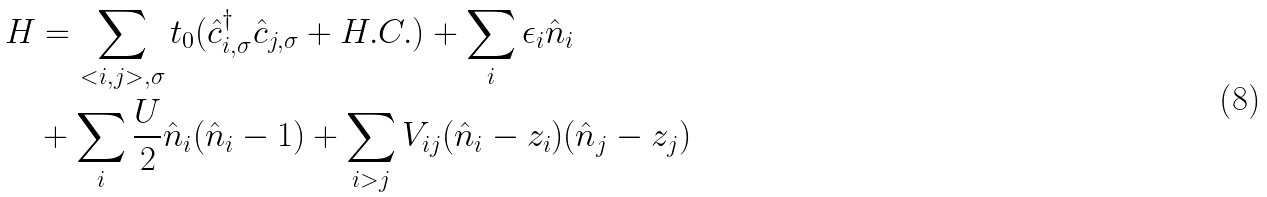Convert formula to latex. <formula><loc_0><loc_0><loc_500><loc_500>H & = \sum _ { < i , j > , \sigma } t _ { 0 } ( \hat { c } _ { i , \sigma } ^ { \dagger } \hat { c } _ { j , \sigma } + H . C . ) + \sum _ { i } \epsilon _ { i } \hat { n } _ { i } \\ & + \sum _ { i } \frac { U } { 2 } \hat { n } _ { i } ( \hat { n } _ { i } - 1 ) + \sum _ { i > j } V _ { i j } ( \hat { n } _ { i } - z _ { i } ) ( \hat { n } _ { j } - z _ { j } )</formula> 